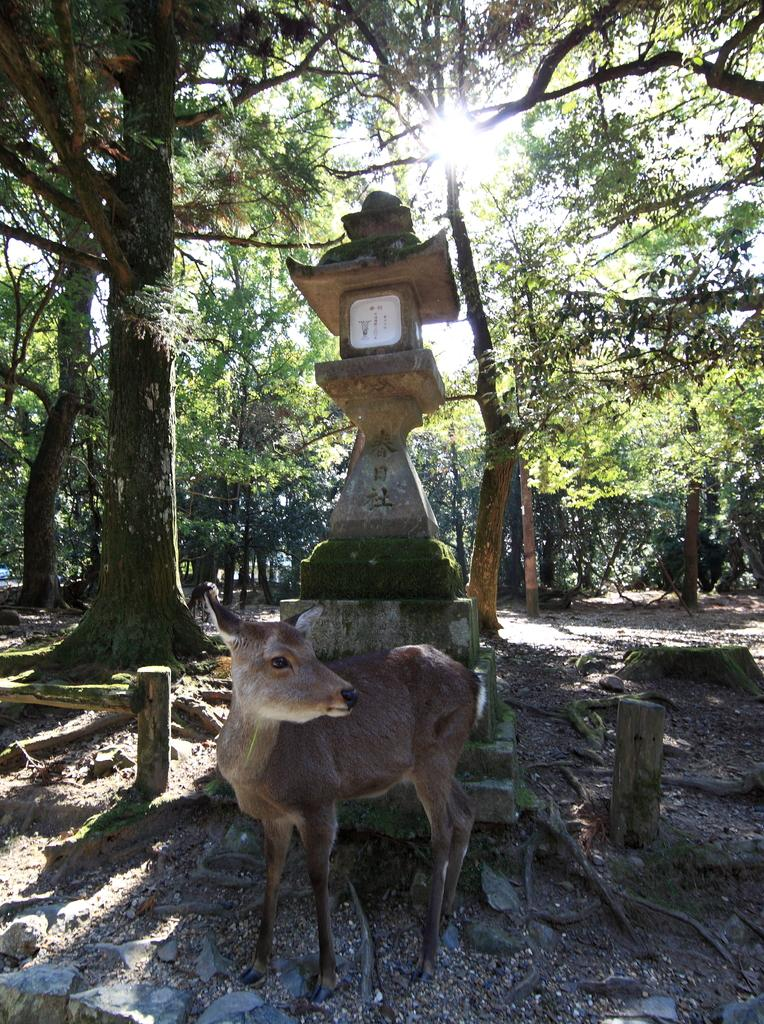What animal can be seen on the ground in the image? There is a deer on the ground in the image. What type of natural environment is depicted in the background of the image? There are trees in the background of the image. What type of structure can be seen in the background of the image? There is a small tower-like structure on the ground in the background. What type of objects are present in the background of the image? There are small wooden poles in the background. What is visible in the sky in the background of the image? The sky is visible in the background of the image. How many bananas are hanging from the trees in the image? There are no bananas present in the image; it features a deer and trees in a natural environment. What type of labor is being performed by the slaves in the image? There are no slaves present in the image; it features a deer and trees in a natural environment. 